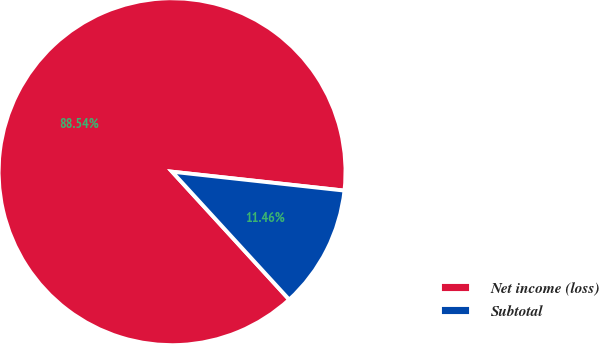Convert chart. <chart><loc_0><loc_0><loc_500><loc_500><pie_chart><fcel>Net income (loss)<fcel>Subtotal<nl><fcel>88.54%<fcel>11.46%<nl></chart> 